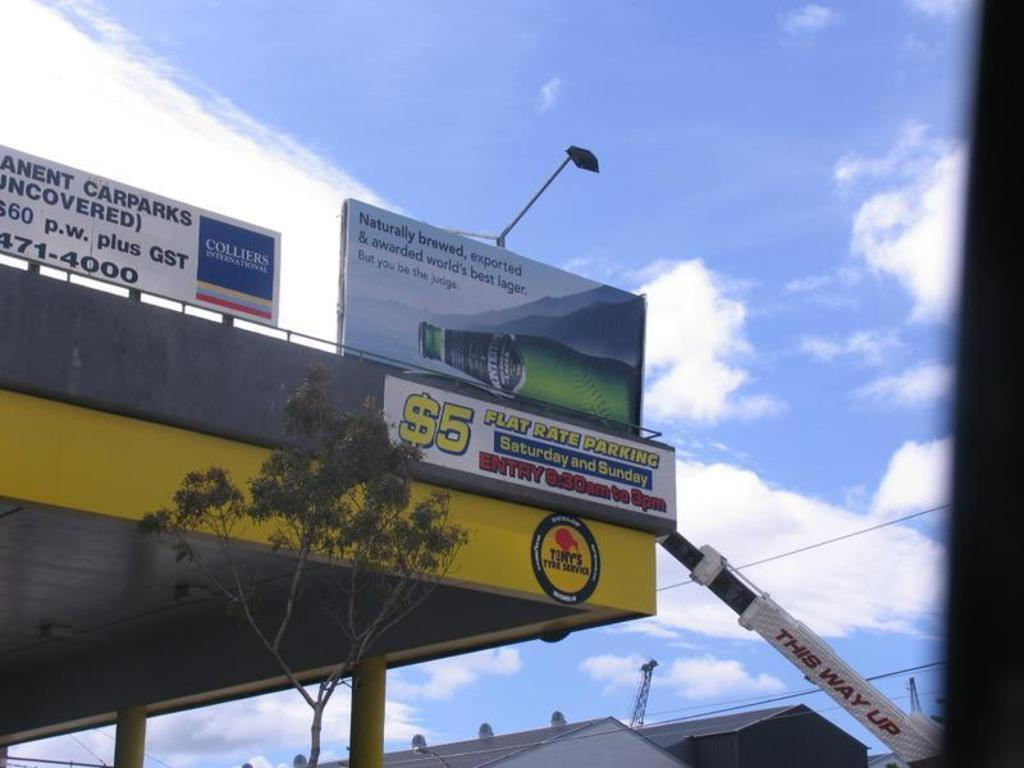<image>
Give a short and clear explanation of the subsequent image. One can park there car here for $5 on Saturdays and Sundays. 